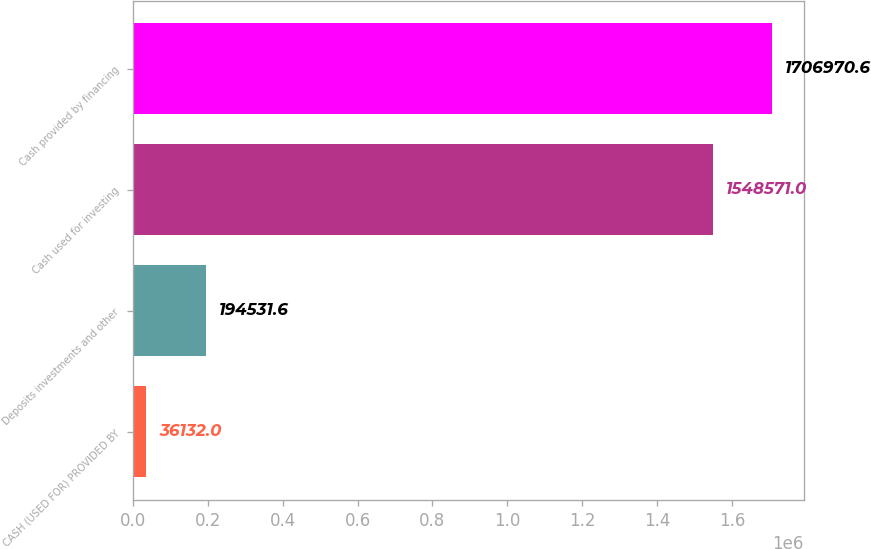Convert chart to OTSL. <chart><loc_0><loc_0><loc_500><loc_500><bar_chart><fcel>CASH (USED FOR) PROVIDED BY<fcel>Deposits investments and other<fcel>Cash used for investing<fcel>Cash provided by financing<nl><fcel>36132<fcel>194532<fcel>1.54857e+06<fcel>1.70697e+06<nl></chart> 